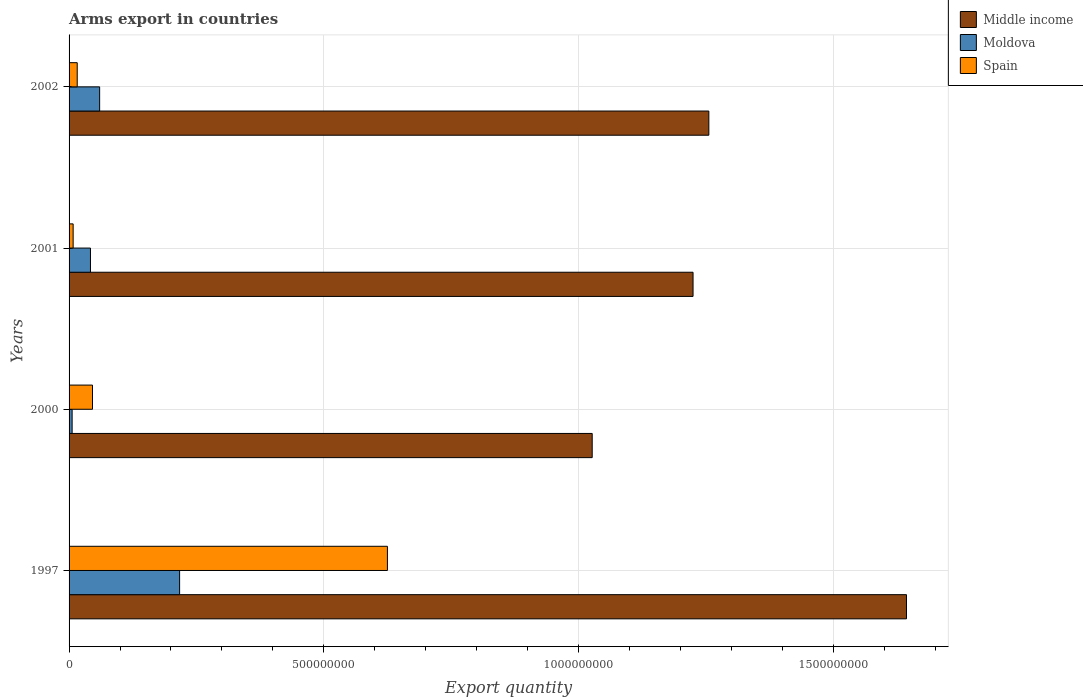How many different coloured bars are there?
Offer a terse response. 3. Are the number of bars per tick equal to the number of legend labels?
Make the answer very short. Yes. How many bars are there on the 4th tick from the top?
Give a very brief answer. 3. How many bars are there on the 1st tick from the bottom?
Keep it short and to the point. 3. What is the label of the 2nd group of bars from the top?
Your response must be concise. 2001. What is the total arms export in Middle income in 1997?
Your answer should be very brief. 1.64e+09. Across all years, what is the maximum total arms export in Moldova?
Make the answer very short. 2.17e+08. What is the total total arms export in Middle income in the graph?
Offer a very short reply. 5.15e+09. What is the difference between the total arms export in Moldova in 1997 and that in 2001?
Offer a very short reply. 1.75e+08. What is the difference between the total arms export in Middle income in 2000 and the total arms export in Moldova in 2001?
Your answer should be compact. 9.85e+08. What is the average total arms export in Moldova per year?
Provide a short and direct response. 8.12e+07. In the year 1997, what is the difference between the total arms export in Moldova and total arms export in Spain?
Give a very brief answer. -4.08e+08. In how many years, is the total arms export in Spain greater than 500000000 ?
Your response must be concise. 1. What is the ratio of the total arms export in Spain in 2000 to that in 2001?
Offer a very short reply. 5.75. Is the difference between the total arms export in Moldova in 1997 and 2002 greater than the difference between the total arms export in Spain in 1997 and 2002?
Your answer should be very brief. No. What is the difference between the highest and the second highest total arms export in Spain?
Make the answer very short. 5.79e+08. What is the difference between the highest and the lowest total arms export in Middle income?
Ensure brevity in your answer.  6.17e+08. What does the 3rd bar from the bottom in 2000 represents?
Your answer should be compact. Spain. How many bars are there?
Keep it short and to the point. 12. Are all the bars in the graph horizontal?
Keep it short and to the point. Yes. What is the difference between two consecutive major ticks on the X-axis?
Keep it short and to the point. 5.00e+08. Are the values on the major ticks of X-axis written in scientific E-notation?
Your answer should be very brief. No. Does the graph contain any zero values?
Offer a very short reply. No. Does the graph contain grids?
Offer a very short reply. Yes. Where does the legend appear in the graph?
Your answer should be very brief. Top right. How many legend labels are there?
Keep it short and to the point. 3. What is the title of the graph?
Provide a succinct answer. Arms export in countries. What is the label or title of the X-axis?
Provide a short and direct response. Export quantity. What is the Export quantity in Middle income in 1997?
Your answer should be compact. 1.64e+09. What is the Export quantity in Moldova in 1997?
Provide a short and direct response. 2.17e+08. What is the Export quantity of Spain in 1997?
Give a very brief answer. 6.25e+08. What is the Export quantity in Middle income in 2000?
Offer a terse response. 1.03e+09. What is the Export quantity in Spain in 2000?
Ensure brevity in your answer.  4.60e+07. What is the Export quantity in Middle income in 2001?
Your answer should be very brief. 1.22e+09. What is the Export quantity of Moldova in 2001?
Your answer should be compact. 4.20e+07. What is the Export quantity of Spain in 2001?
Make the answer very short. 8.00e+06. What is the Export quantity of Middle income in 2002?
Provide a short and direct response. 1.26e+09. What is the Export quantity of Moldova in 2002?
Your answer should be compact. 6.00e+07. What is the Export quantity in Spain in 2002?
Ensure brevity in your answer.  1.60e+07. Across all years, what is the maximum Export quantity of Middle income?
Your answer should be compact. 1.64e+09. Across all years, what is the maximum Export quantity in Moldova?
Your answer should be compact. 2.17e+08. Across all years, what is the maximum Export quantity in Spain?
Offer a very short reply. 6.25e+08. Across all years, what is the minimum Export quantity of Middle income?
Give a very brief answer. 1.03e+09. Across all years, what is the minimum Export quantity in Moldova?
Offer a terse response. 6.00e+06. Across all years, what is the minimum Export quantity in Spain?
Ensure brevity in your answer.  8.00e+06. What is the total Export quantity in Middle income in the graph?
Your answer should be compact. 5.15e+09. What is the total Export quantity in Moldova in the graph?
Your response must be concise. 3.25e+08. What is the total Export quantity in Spain in the graph?
Offer a very short reply. 6.95e+08. What is the difference between the Export quantity of Middle income in 1997 and that in 2000?
Your response must be concise. 6.17e+08. What is the difference between the Export quantity of Moldova in 1997 and that in 2000?
Offer a very short reply. 2.11e+08. What is the difference between the Export quantity of Spain in 1997 and that in 2000?
Your answer should be compact. 5.79e+08. What is the difference between the Export quantity in Middle income in 1997 and that in 2001?
Make the answer very short. 4.19e+08. What is the difference between the Export quantity of Moldova in 1997 and that in 2001?
Your answer should be compact. 1.75e+08. What is the difference between the Export quantity in Spain in 1997 and that in 2001?
Provide a short and direct response. 6.17e+08. What is the difference between the Export quantity of Middle income in 1997 and that in 2002?
Offer a terse response. 3.88e+08. What is the difference between the Export quantity in Moldova in 1997 and that in 2002?
Ensure brevity in your answer.  1.57e+08. What is the difference between the Export quantity of Spain in 1997 and that in 2002?
Provide a succinct answer. 6.09e+08. What is the difference between the Export quantity of Middle income in 2000 and that in 2001?
Make the answer very short. -1.98e+08. What is the difference between the Export quantity of Moldova in 2000 and that in 2001?
Keep it short and to the point. -3.60e+07. What is the difference between the Export quantity of Spain in 2000 and that in 2001?
Keep it short and to the point. 3.80e+07. What is the difference between the Export quantity in Middle income in 2000 and that in 2002?
Your response must be concise. -2.29e+08. What is the difference between the Export quantity of Moldova in 2000 and that in 2002?
Provide a short and direct response. -5.40e+07. What is the difference between the Export quantity of Spain in 2000 and that in 2002?
Your answer should be very brief. 3.00e+07. What is the difference between the Export quantity of Middle income in 2001 and that in 2002?
Your response must be concise. -3.10e+07. What is the difference between the Export quantity of Moldova in 2001 and that in 2002?
Ensure brevity in your answer.  -1.80e+07. What is the difference between the Export quantity in Spain in 2001 and that in 2002?
Ensure brevity in your answer.  -8.00e+06. What is the difference between the Export quantity in Middle income in 1997 and the Export quantity in Moldova in 2000?
Your answer should be very brief. 1.64e+09. What is the difference between the Export quantity in Middle income in 1997 and the Export quantity in Spain in 2000?
Your answer should be compact. 1.60e+09. What is the difference between the Export quantity in Moldova in 1997 and the Export quantity in Spain in 2000?
Offer a terse response. 1.71e+08. What is the difference between the Export quantity of Middle income in 1997 and the Export quantity of Moldova in 2001?
Keep it short and to the point. 1.60e+09. What is the difference between the Export quantity in Middle income in 1997 and the Export quantity in Spain in 2001?
Ensure brevity in your answer.  1.64e+09. What is the difference between the Export quantity in Moldova in 1997 and the Export quantity in Spain in 2001?
Make the answer very short. 2.09e+08. What is the difference between the Export quantity in Middle income in 1997 and the Export quantity in Moldova in 2002?
Provide a succinct answer. 1.58e+09. What is the difference between the Export quantity in Middle income in 1997 and the Export quantity in Spain in 2002?
Provide a succinct answer. 1.63e+09. What is the difference between the Export quantity in Moldova in 1997 and the Export quantity in Spain in 2002?
Provide a succinct answer. 2.01e+08. What is the difference between the Export quantity in Middle income in 2000 and the Export quantity in Moldova in 2001?
Your response must be concise. 9.85e+08. What is the difference between the Export quantity in Middle income in 2000 and the Export quantity in Spain in 2001?
Offer a very short reply. 1.02e+09. What is the difference between the Export quantity in Middle income in 2000 and the Export quantity in Moldova in 2002?
Ensure brevity in your answer.  9.67e+08. What is the difference between the Export quantity of Middle income in 2000 and the Export quantity of Spain in 2002?
Make the answer very short. 1.01e+09. What is the difference between the Export quantity of Moldova in 2000 and the Export quantity of Spain in 2002?
Make the answer very short. -1.00e+07. What is the difference between the Export quantity in Middle income in 2001 and the Export quantity in Moldova in 2002?
Your answer should be very brief. 1.16e+09. What is the difference between the Export quantity in Middle income in 2001 and the Export quantity in Spain in 2002?
Ensure brevity in your answer.  1.21e+09. What is the difference between the Export quantity in Moldova in 2001 and the Export quantity in Spain in 2002?
Keep it short and to the point. 2.60e+07. What is the average Export quantity in Middle income per year?
Your response must be concise. 1.29e+09. What is the average Export quantity of Moldova per year?
Keep it short and to the point. 8.12e+07. What is the average Export quantity in Spain per year?
Ensure brevity in your answer.  1.74e+08. In the year 1997, what is the difference between the Export quantity in Middle income and Export quantity in Moldova?
Offer a terse response. 1.43e+09. In the year 1997, what is the difference between the Export quantity in Middle income and Export quantity in Spain?
Make the answer very short. 1.02e+09. In the year 1997, what is the difference between the Export quantity in Moldova and Export quantity in Spain?
Offer a very short reply. -4.08e+08. In the year 2000, what is the difference between the Export quantity in Middle income and Export quantity in Moldova?
Provide a succinct answer. 1.02e+09. In the year 2000, what is the difference between the Export quantity of Middle income and Export quantity of Spain?
Your answer should be very brief. 9.81e+08. In the year 2000, what is the difference between the Export quantity of Moldova and Export quantity of Spain?
Your answer should be compact. -4.00e+07. In the year 2001, what is the difference between the Export quantity in Middle income and Export quantity in Moldova?
Your answer should be very brief. 1.18e+09. In the year 2001, what is the difference between the Export quantity of Middle income and Export quantity of Spain?
Your response must be concise. 1.22e+09. In the year 2001, what is the difference between the Export quantity of Moldova and Export quantity of Spain?
Provide a succinct answer. 3.40e+07. In the year 2002, what is the difference between the Export quantity in Middle income and Export quantity in Moldova?
Offer a terse response. 1.20e+09. In the year 2002, what is the difference between the Export quantity of Middle income and Export quantity of Spain?
Provide a succinct answer. 1.24e+09. In the year 2002, what is the difference between the Export quantity in Moldova and Export quantity in Spain?
Your answer should be compact. 4.40e+07. What is the ratio of the Export quantity of Middle income in 1997 to that in 2000?
Provide a short and direct response. 1.6. What is the ratio of the Export quantity of Moldova in 1997 to that in 2000?
Your answer should be very brief. 36.17. What is the ratio of the Export quantity of Spain in 1997 to that in 2000?
Give a very brief answer. 13.59. What is the ratio of the Export quantity of Middle income in 1997 to that in 2001?
Your answer should be compact. 1.34. What is the ratio of the Export quantity of Moldova in 1997 to that in 2001?
Provide a succinct answer. 5.17. What is the ratio of the Export quantity of Spain in 1997 to that in 2001?
Provide a short and direct response. 78.12. What is the ratio of the Export quantity of Middle income in 1997 to that in 2002?
Offer a terse response. 1.31. What is the ratio of the Export quantity in Moldova in 1997 to that in 2002?
Your answer should be very brief. 3.62. What is the ratio of the Export quantity of Spain in 1997 to that in 2002?
Your response must be concise. 39.06. What is the ratio of the Export quantity in Middle income in 2000 to that in 2001?
Offer a very short reply. 0.84. What is the ratio of the Export quantity of Moldova in 2000 to that in 2001?
Offer a terse response. 0.14. What is the ratio of the Export quantity of Spain in 2000 to that in 2001?
Offer a terse response. 5.75. What is the ratio of the Export quantity of Middle income in 2000 to that in 2002?
Give a very brief answer. 0.82. What is the ratio of the Export quantity of Spain in 2000 to that in 2002?
Provide a succinct answer. 2.88. What is the ratio of the Export quantity in Middle income in 2001 to that in 2002?
Provide a succinct answer. 0.98. What is the ratio of the Export quantity of Moldova in 2001 to that in 2002?
Ensure brevity in your answer.  0.7. What is the ratio of the Export quantity in Spain in 2001 to that in 2002?
Provide a succinct answer. 0.5. What is the difference between the highest and the second highest Export quantity in Middle income?
Provide a succinct answer. 3.88e+08. What is the difference between the highest and the second highest Export quantity in Moldova?
Your answer should be compact. 1.57e+08. What is the difference between the highest and the second highest Export quantity in Spain?
Your answer should be compact. 5.79e+08. What is the difference between the highest and the lowest Export quantity in Middle income?
Your answer should be very brief. 6.17e+08. What is the difference between the highest and the lowest Export quantity in Moldova?
Provide a short and direct response. 2.11e+08. What is the difference between the highest and the lowest Export quantity in Spain?
Provide a short and direct response. 6.17e+08. 